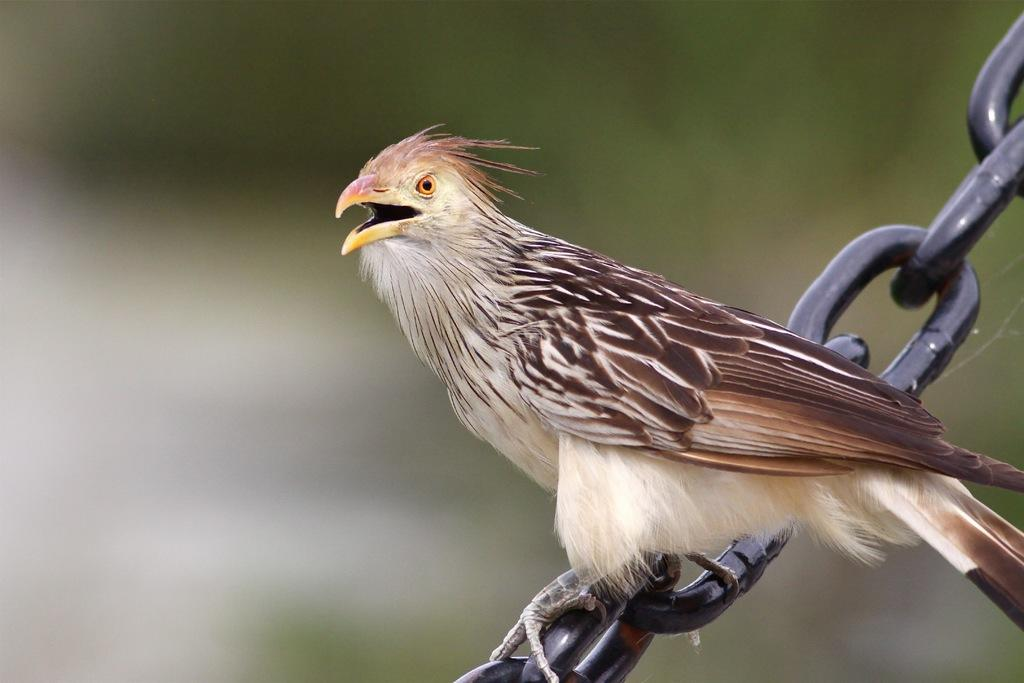What type of animal is present in the image? There is a bird in the image. What is the bird doing in the image? The bird is sitting on an iron chain. What type of apparel is the farmer wearing in the image? There is no farmer present in the image. What type of surprise is the bird holding in its beak in the image? There is no surprise visible in the image; the bird is simply sitting on an iron chain. 